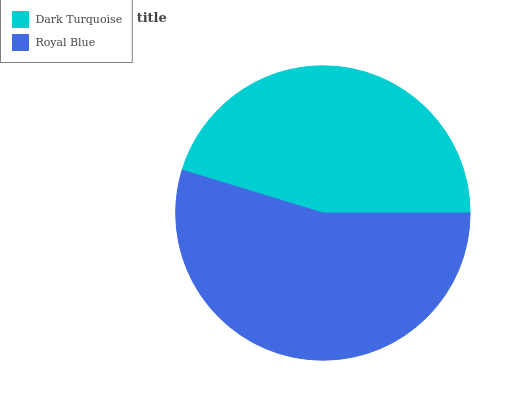Is Dark Turquoise the minimum?
Answer yes or no. Yes. Is Royal Blue the maximum?
Answer yes or no. Yes. Is Royal Blue the minimum?
Answer yes or no. No. Is Royal Blue greater than Dark Turquoise?
Answer yes or no. Yes. Is Dark Turquoise less than Royal Blue?
Answer yes or no. Yes. Is Dark Turquoise greater than Royal Blue?
Answer yes or no. No. Is Royal Blue less than Dark Turquoise?
Answer yes or no. No. Is Royal Blue the high median?
Answer yes or no. Yes. Is Dark Turquoise the low median?
Answer yes or no. Yes. Is Dark Turquoise the high median?
Answer yes or no. No. Is Royal Blue the low median?
Answer yes or no. No. 